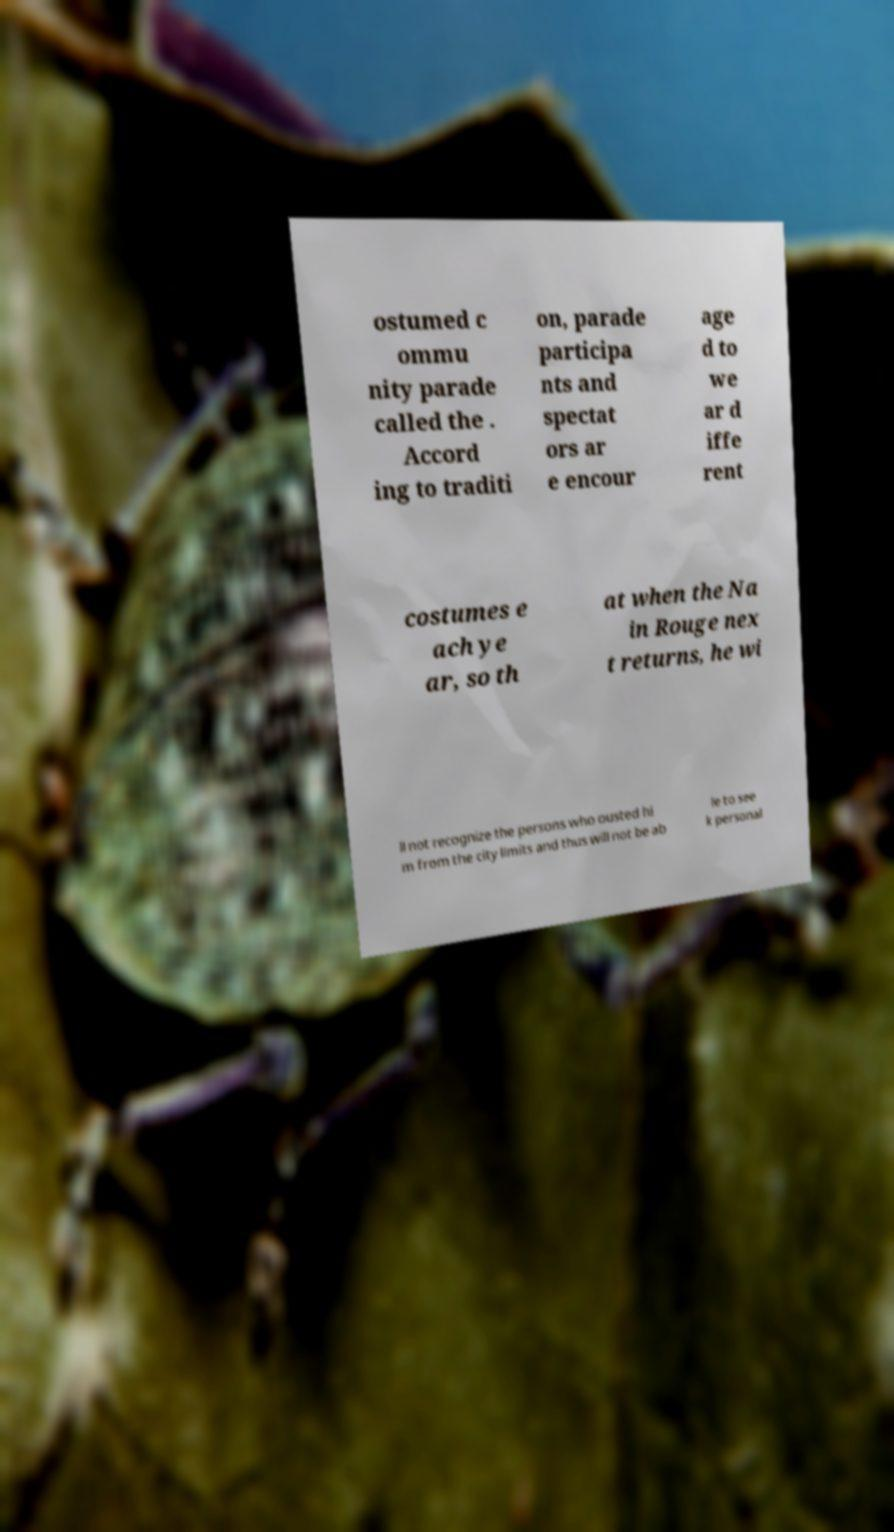What messages or text are displayed in this image? I need them in a readable, typed format. ostumed c ommu nity parade called the . Accord ing to traditi on, parade participa nts and spectat ors ar e encour age d to we ar d iffe rent costumes e ach ye ar, so th at when the Na in Rouge nex t returns, he wi ll not recognize the persons who ousted hi m from the city limits and thus will not be ab le to see k personal 